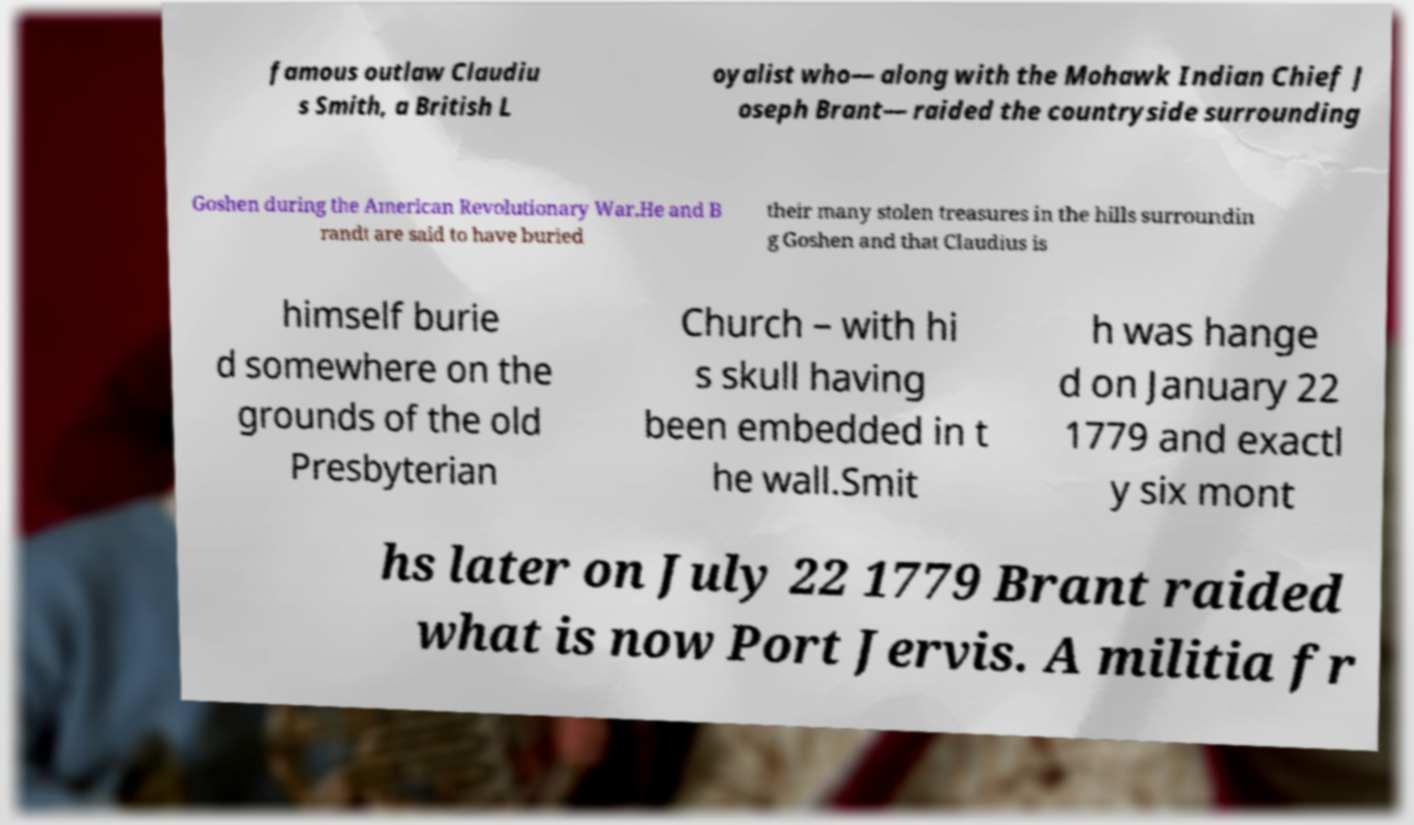Can you read and provide the text displayed in the image?This photo seems to have some interesting text. Can you extract and type it out for me? famous outlaw Claudiu s Smith, a British L oyalist who— along with the Mohawk Indian Chief J oseph Brant— raided the countryside surrounding Goshen during the American Revolutionary War.He and B randt are said to have buried their many stolen treasures in the hills surroundin g Goshen and that Claudius is himself burie d somewhere on the grounds of the old Presbyterian Church – with hi s skull having been embedded in t he wall.Smit h was hange d on January 22 1779 and exactl y six mont hs later on July 22 1779 Brant raided what is now Port Jervis. A militia fr 